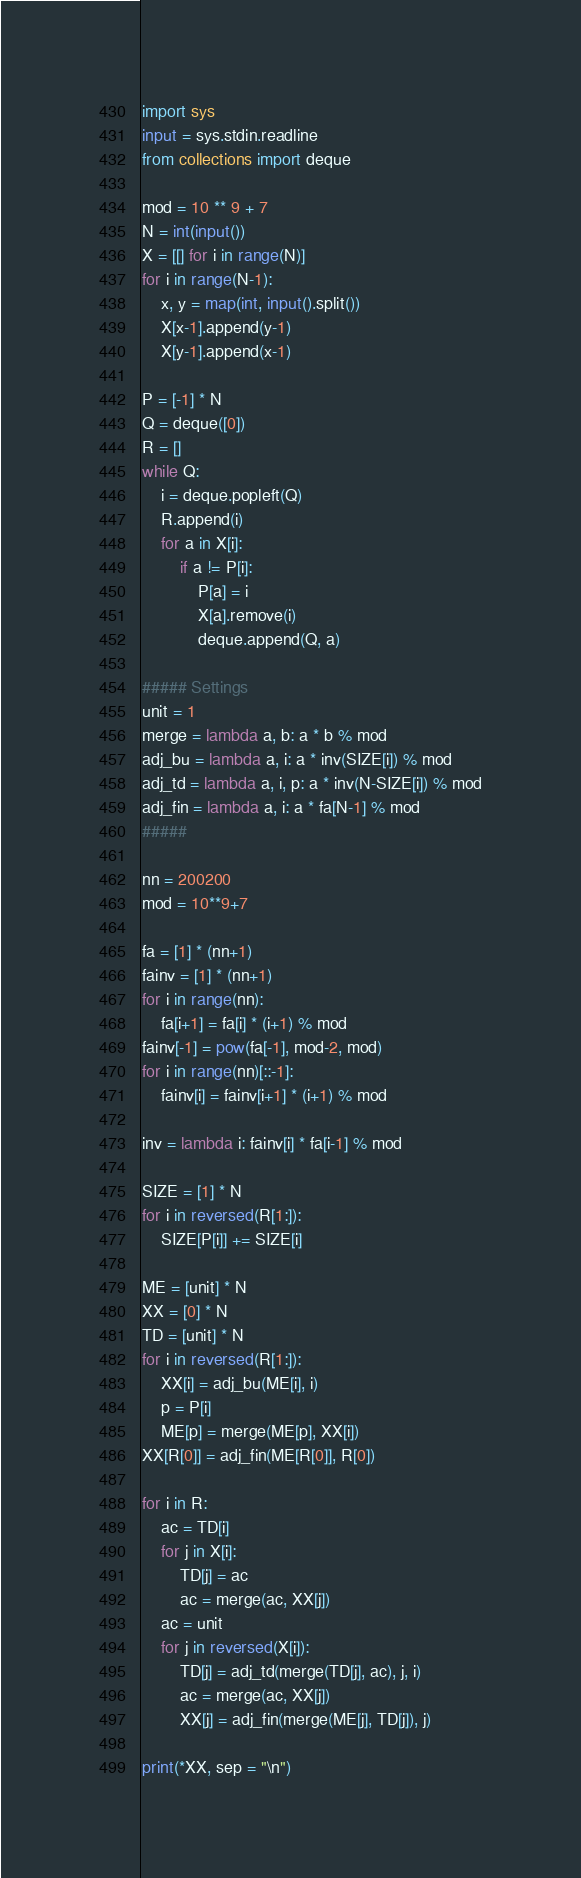Convert code to text. <code><loc_0><loc_0><loc_500><loc_500><_Python_>import sys
input = sys.stdin.readline
from collections import deque

mod = 10 ** 9 + 7
N = int(input())
X = [[] for i in range(N)]
for i in range(N-1):
    x, y = map(int, input().split())
    X[x-1].append(y-1)
    X[y-1].append(x-1)

P = [-1] * N
Q = deque([0])
R = []
while Q:
    i = deque.popleft(Q)
    R.append(i)
    for a in X[i]:
        if a != P[i]:
            P[a] = i
            X[a].remove(i)
            deque.append(Q, a)

##### Settings
unit = 1
merge = lambda a, b: a * b % mod
adj_bu = lambda a, i: a * inv(SIZE[i]) % mod
adj_td = lambda a, i, p: a * inv(N-SIZE[i]) % mod
adj_fin = lambda a, i: a * fa[N-1] % mod
#####

nn = 200200
mod = 10**9+7

fa = [1] * (nn+1)
fainv = [1] * (nn+1)
for i in range(nn):
    fa[i+1] = fa[i] * (i+1) % mod
fainv[-1] = pow(fa[-1], mod-2, mod)
for i in range(nn)[::-1]:
    fainv[i] = fainv[i+1] * (i+1) % mod

inv = lambda i: fainv[i] * fa[i-1] % mod

SIZE = [1] * N
for i in reversed(R[1:]):
    SIZE[P[i]] += SIZE[i]

ME = [unit] * N
XX = [0] * N
TD = [unit] * N
for i in reversed(R[1:]):
    XX[i] = adj_bu(ME[i], i)
    p = P[i]
    ME[p] = merge(ME[p], XX[i])
XX[R[0]] = adj_fin(ME[R[0]], R[0])

for i in R:
    ac = TD[i]
    for j in X[i]:
        TD[j] = ac
        ac = merge(ac, XX[j])
    ac = unit
    for j in reversed(X[i]):
        TD[j] = adj_td(merge(TD[j], ac), j, i)
        ac = merge(ac, XX[j])
        XX[j] = adj_fin(merge(ME[j], TD[j]), j)

print(*XX, sep = "\n")</code> 